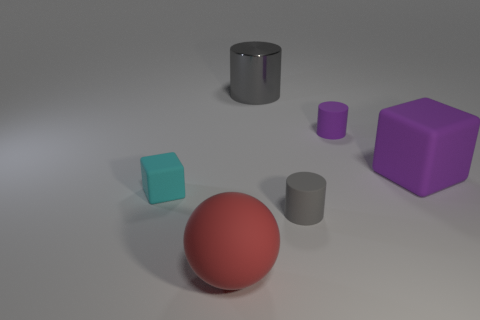Are there any other rubber things of the same shape as the large purple thing?
Provide a short and direct response. Yes. Are the gray object that is in front of the big matte block and the gray cylinder that is to the left of the small gray cylinder made of the same material?
Offer a terse response. No. There is a block behind the rubber block in front of the large matte thing behind the cyan object; what is its size?
Offer a terse response. Large. There is a gray object that is the same size as the purple rubber block; what material is it?
Make the answer very short. Metal. Are there any purple objects that have the same size as the sphere?
Make the answer very short. Yes. Do the cyan matte thing and the gray rubber thing have the same shape?
Ensure brevity in your answer.  No. Is there a tiny purple cylinder in front of the cylinder behind the purple rubber cylinder that is on the right side of the big gray thing?
Your response must be concise. Yes. How many other things are there of the same color as the rubber sphere?
Give a very brief answer. 0. Is the size of the cylinder that is in front of the big purple rubber block the same as the red thing in front of the big cube?
Offer a very short reply. No. Are there an equal number of tiny purple things in front of the big sphere and matte objects on the left side of the big metal cylinder?
Ensure brevity in your answer.  No. 